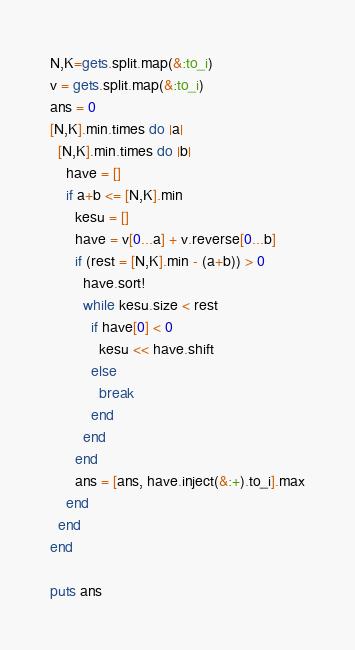Convert code to text. <code><loc_0><loc_0><loc_500><loc_500><_Ruby_>N,K=gets.split.map(&:to_i)
v = gets.split.map(&:to_i)
ans = 0
[N,K].min.times do |a|
  [N,K].min.times do |b|
    have = []
    if a+b <= [N,K].min
      kesu = []
      have = v[0...a] + v.reverse[0...b]
      if (rest = [N,K].min - (a+b)) > 0
        have.sort!
        while kesu.size < rest
          if have[0] < 0
            kesu << have.shift
          else
            break
          end
        end
      end
      ans = [ans, have.inject(&:+).to_i].max
    end
  end
end

puts ans

</code> 